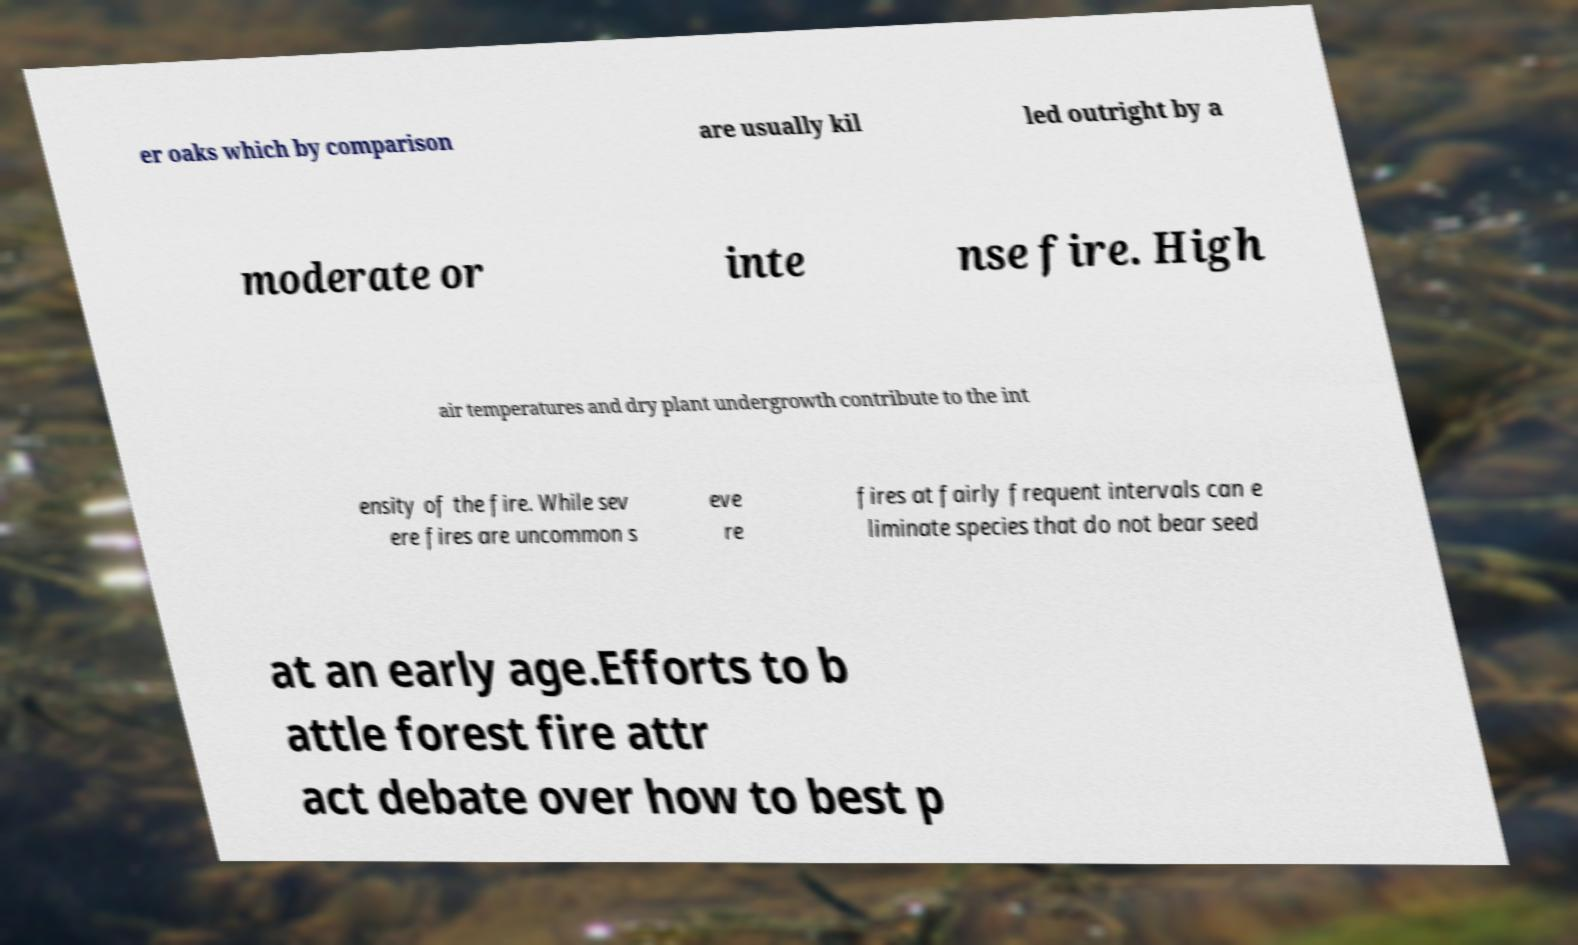What messages or text are displayed in this image? I need them in a readable, typed format. er oaks which by comparison are usually kil led outright by a moderate or inte nse fire. High air temperatures and dry plant undergrowth contribute to the int ensity of the fire. While sev ere fires are uncommon s eve re fires at fairly frequent intervals can e liminate species that do not bear seed at an early age.Efforts to b attle forest fire attr act debate over how to best p 